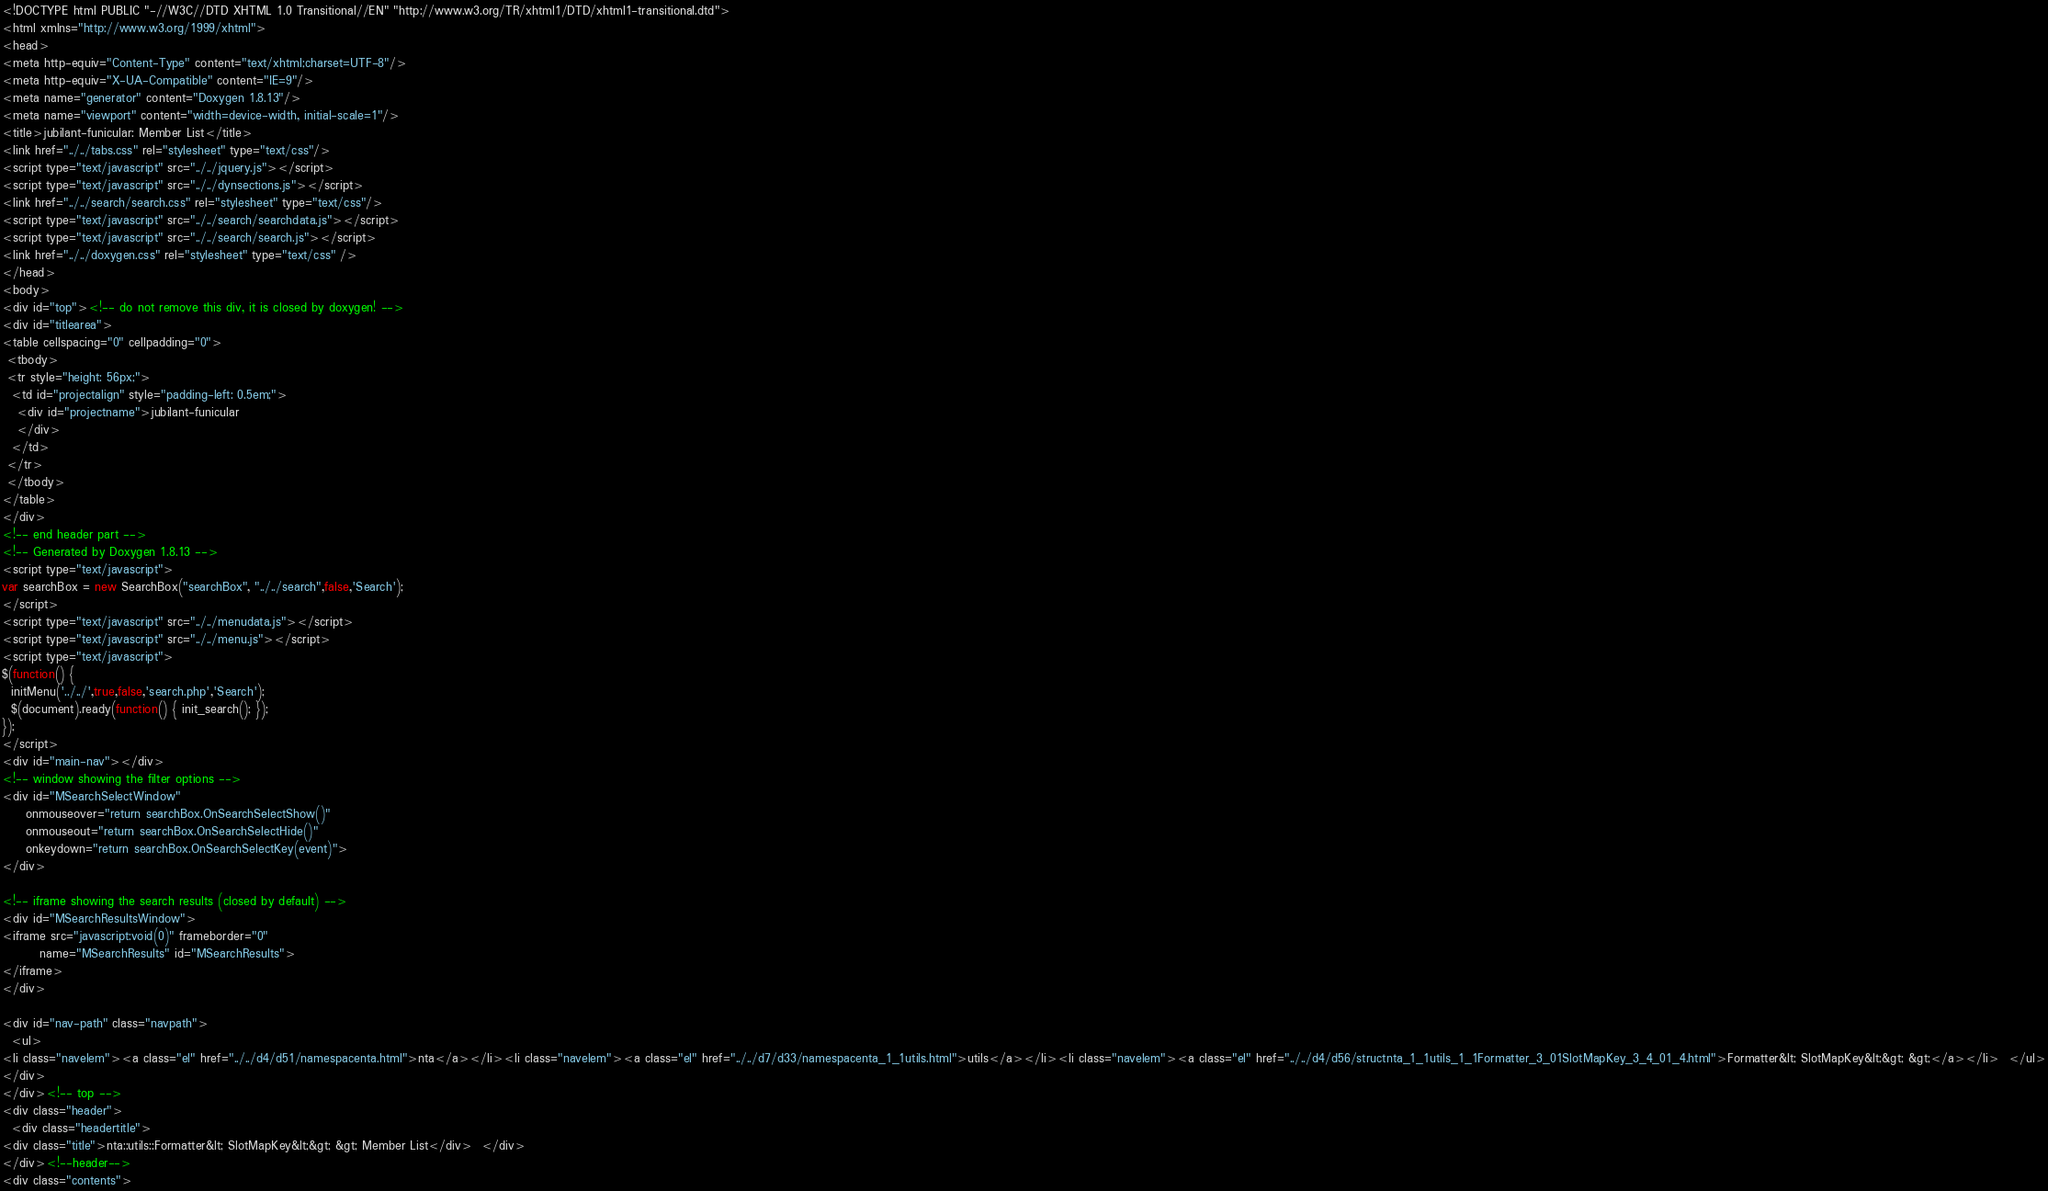<code> <loc_0><loc_0><loc_500><loc_500><_HTML_><!DOCTYPE html PUBLIC "-//W3C//DTD XHTML 1.0 Transitional//EN" "http://www.w3.org/TR/xhtml1/DTD/xhtml1-transitional.dtd">
<html xmlns="http://www.w3.org/1999/xhtml">
<head>
<meta http-equiv="Content-Type" content="text/xhtml;charset=UTF-8"/>
<meta http-equiv="X-UA-Compatible" content="IE=9"/>
<meta name="generator" content="Doxygen 1.8.13"/>
<meta name="viewport" content="width=device-width, initial-scale=1"/>
<title>jubilant-funicular: Member List</title>
<link href="../../tabs.css" rel="stylesheet" type="text/css"/>
<script type="text/javascript" src="../../jquery.js"></script>
<script type="text/javascript" src="../../dynsections.js"></script>
<link href="../../search/search.css" rel="stylesheet" type="text/css"/>
<script type="text/javascript" src="../../search/searchdata.js"></script>
<script type="text/javascript" src="../../search/search.js"></script>
<link href="../../doxygen.css" rel="stylesheet" type="text/css" />
</head>
<body>
<div id="top"><!-- do not remove this div, it is closed by doxygen! -->
<div id="titlearea">
<table cellspacing="0" cellpadding="0">
 <tbody>
 <tr style="height: 56px;">
  <td id="projectalign" style="padding-left: 0.5em;">
   <div id="projectname">jubilant-funicular
   </div>
  </td>
 </tr>
 </tbody>
</table>
</div>
<!-- end header part -->
<!-- Generated by Doxygen 1.8.13 -->
<script type="text/javascript">
var searchBox = new SearchBox("searchBox", "../../search",false,'Search');
</script>
<script type="text/javascript" src="../../menudata.js"></script>
<script type="text/javascript" src="../../menu.js"></script>
<script type="text/javascript">
$(function() {
  initMenu('../../',true,false,'search.php','Search');
  $(document).ready(function() { init_search(); });
});
</script>
<div id="main-nav"></div>
<!-- window showing the filter options -->
<div id="MSearchSelectWindow"
     onmouseover="return searchBox.OnSearchSelectShow()"
     onmouseout="return searchBox.OnSearchSelectHide()"
     onkeydown="return searchBox.OnSearchSelectKey(event)">
</div>

<!-- iframe showing the search results (closed by default) -->
<div id="MSearchResultsWindow">
<iframe src="javascript:void(0)" frameborder="0" 
        name="MSearchResults" id="MSearchResults">
</iframe>
</div>

<div id="nav-path" class="navpath">
  <ul>
<li class="navelem"><a class="el" href="../../d4/d51/namespacenta.html">nta</a></li><li class="navelem"><a class="el" href="../../d7/d33/namespacenta_1_1utils.html">utils</a></li><li class="navelem"><a class="el" href="../../d4/d56/structnta_1_1utils_1_1Formatter_3_01SlotMapKey_3_4_01_4.html">Formatter&lt; SlotMapKey&lt;&gt; &gt;</a></li>  </ul>
</div>
</div><!-- top -->
<div class="header">
  <div class="headertitle">
<div class="title">nta::utils::Formatter&lt; SlotMapKey&lt;&gt; &gt; Member List</div>  </div>
</div><!--header-->
<div class="contents">
</code> 